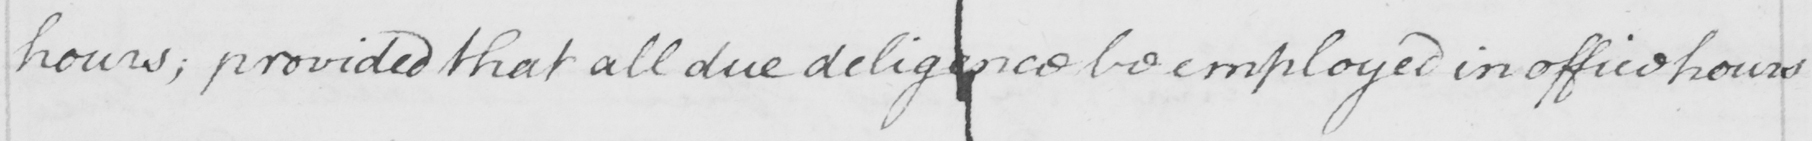Please provide the text content of this handwritten line. hours , provided that all due diligence be employed in office hours 